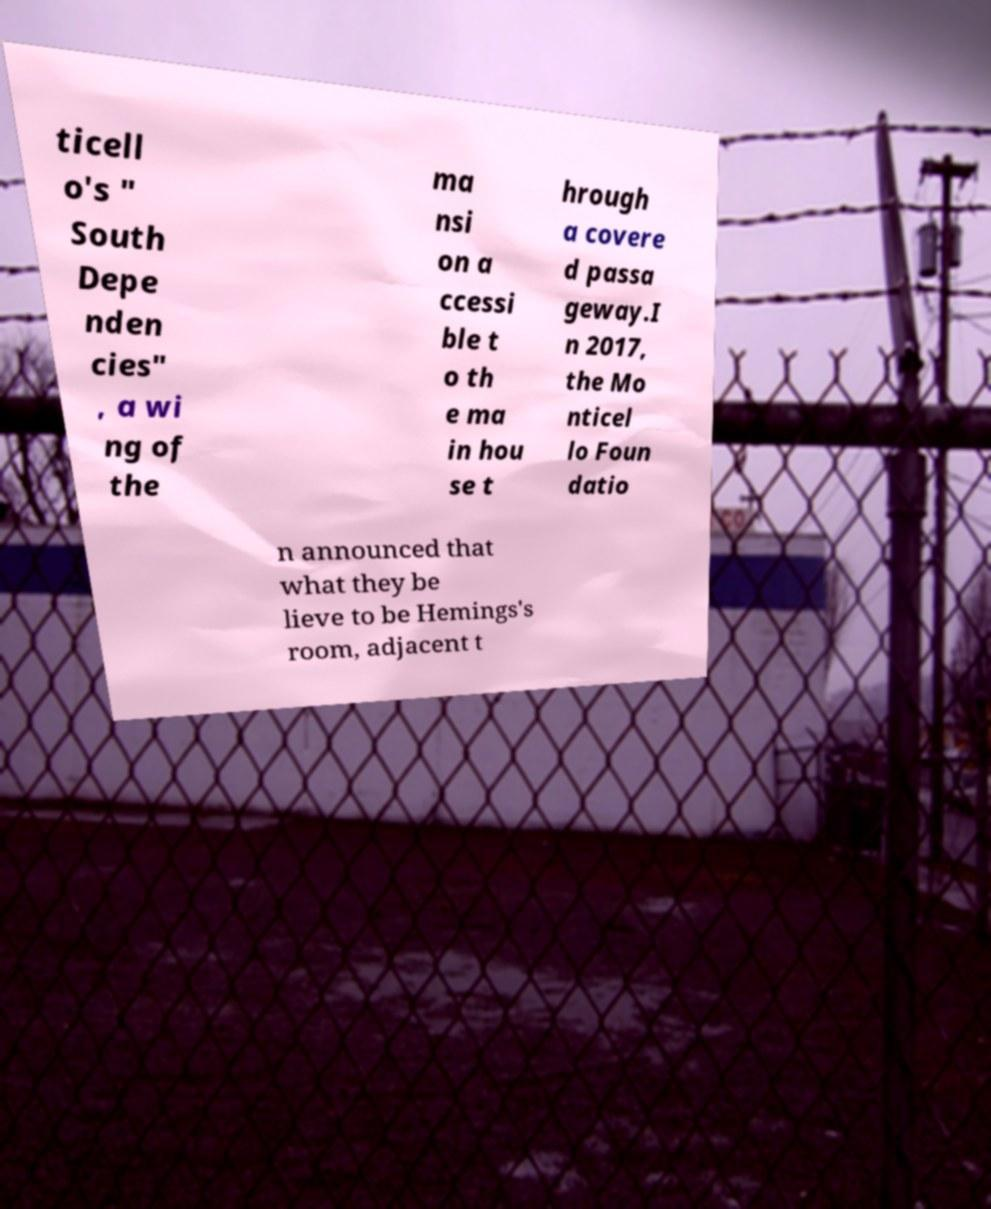Please read and relay the text visible in this image. What does it say? ticell o's " South Depe nden cies" , a wi ng of the ma nsi on a ccessi ble t o th e ma in hou se t hrough a covere d passa geway.I n 2017, the Mo nticel lo Foun datio n announced that what they be lieve to be Hemings's room, adjacent t 